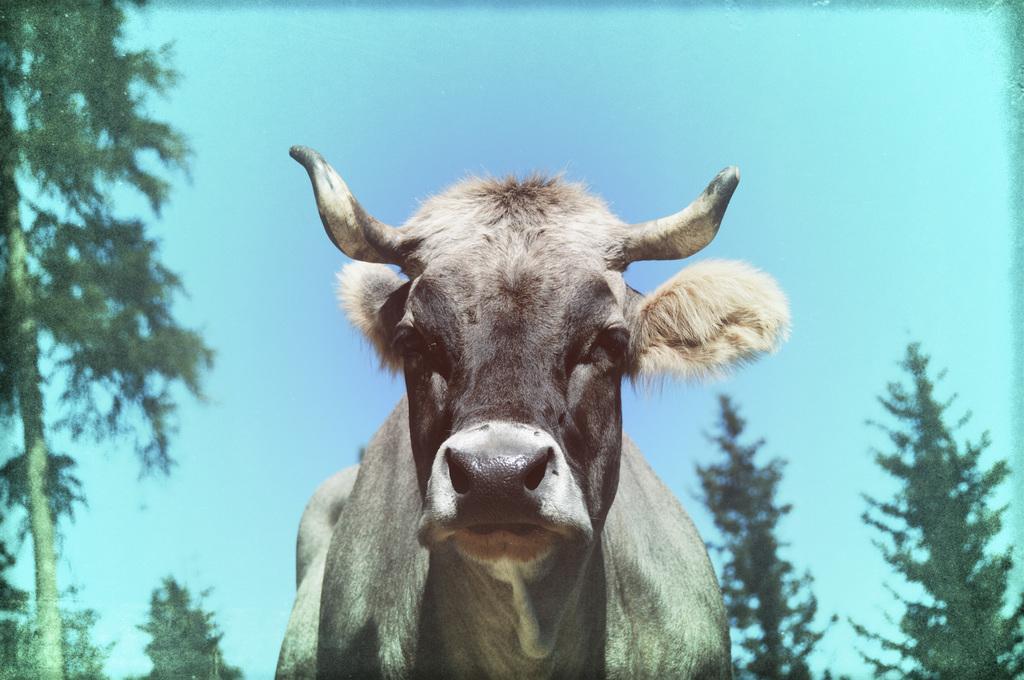Please provide a concise description of this image. Here we can see animal. Background there are trees and sky. 